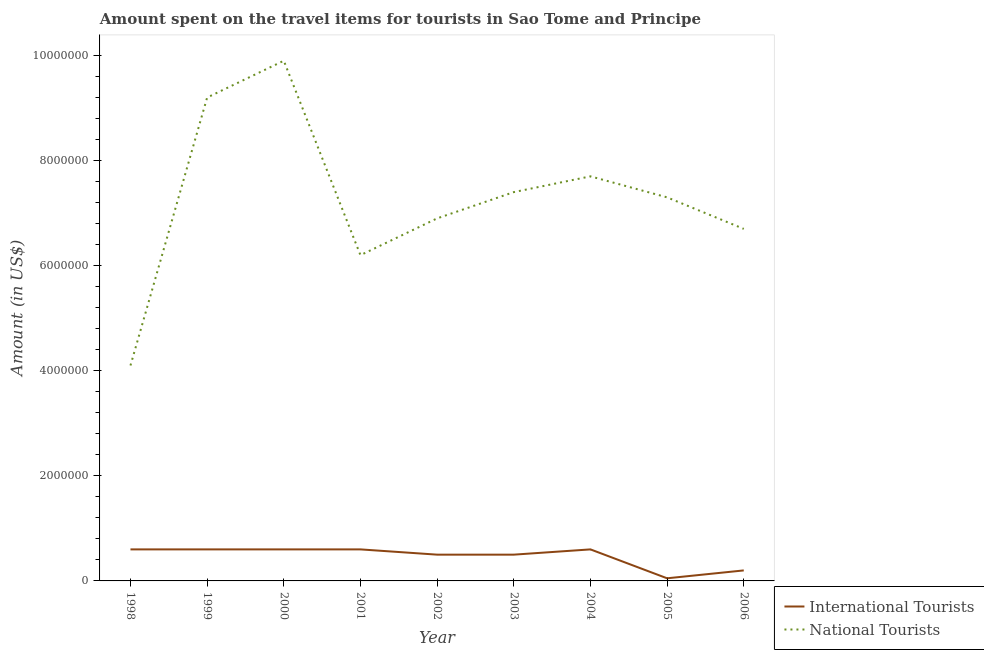Does the line corresponding to amount spent on travel items of international tourists intersect with the line corresponding to amount spent on travel items of national tourists?
Keep it short and to the point. No. What is the amount spent on travel items of national tourists in 2000?
Give a very brief answer. 9.90e+06. Across all years, what is the maximum amount spent on travel items of international tourists?
Your answer should be very brief. 6.00e+05. Across all years, what is the minimum amount spent on travel items of international tourists?
Provide a short and direct response. 5.00e+04. In which year was the amount spent on travel items of national tourists maximum?
Ensure brevity in your answer.  2000. What is the total amount spent on travel items of international tourists in the graph?
Provide a succinct answer. 4.25e+06. What is the difference between the amount spent on travel items of national tourists in 2000 and that in 2002?
Ensure brevity in your answer.  3.00e+06. What is the difference between the amount spent on travel items of national tourists in 2003 and the amount spent on travel items of international tourists in 2002?
Keep it short and to the point. 6.90e+06. What is the average amount spent on travel items of national tourists per year?
Provide a succinct answer. 7.27e+06. In the year 1999, what is the difference between the amount spent on travel items of national tourists and amount spent on travel items of international tourists?
Your response must be concise. 8.60e+06. What is the ratio of the amount spent on travel items of international tourists in 1999 to that in 2000?
Offer a very short reply. 1. What is the difference between the highest and the second highest amount spent on travel items of international tourists?
Provide a succinct answer. 0. What is the difference between the highest and the lowest amount spent on travel items of international tourists?
Your answer should be very brief. 5.50e+05. In how many years, is the amount spent on travel items of national tourists greater than the average amount spent on travel items of national tourists taken over all years?
Provide a succinct answer. 5. Is the sum of the amount spent on travel items of international tourists in 2000 and 2004 greater than the maximum amount spent on travel items of national tourists across all years?
Make the answer very short. No. Is the amount spent on travel items of international tourists strictly less than the amount spent on travel items of national tourists over the years?
Offer a terse response. Yes. Does the graph contain any zero values?
Give a very brief answer. No. Does the graph contain grids?
Give a very brief answer. No. Where does the legend appear in the graph?
Keep it short and to the point. Bottom right. How many legend labels are there?
Give a very brief answer. 2. What is the title of the graph?
Make the answer very short. Amount spent on the travel items for tourists in Sao Tome and Principe. Does "Primary completion rate" appear as one of the legend labels in the graph?
Provide a succinct answer. No. What is the label or title of the Y-axis?
Provide a short and direct response. Amount (in US$). What is the Amount (in US$) of National Tourists in 1998?
Offer a very short reply. 4.10e+06. What is the Amount (in US$) of National Tourists in 1999?
Provide a succinct answer. 9.20e+06. What is the Amount (in US$) of National Tourists in 2000?
Give a very brief answer. 9.90e+06. What is the Amount (in US$) in National Tourists in 2001?
Offer a very short reply. 6.20e+06. What is the Amount (in US$) of National Tourists in 2002?
Give a very brief answer. 6.90e+06. What is the Amount (in US$) in National Tourists in 2003?
Keep it short and to the point. 7.40e+06. What is the Amount (in US$) of National Tourists in 2004?
Give a very brief answer. 7.70e+06. What is the Amount (in US$) of International Tourists in 2005?
Provide a succinct answer. 5.00e+04. What is the Amount (in US$) in National Tourists in 2005?
Provide a short and direct response. 7.30e+06. What is the Amount (in US$) of National Tourists in 2006?
Your answer should be very brief. 6.70e+06. Across all years, what is the maximum Amount (in US$) in International Tourists?
Ensure brevity in your answer.  6.00e+05. Across all years, what is the maximum Amount (in US$) in National Tourists?
Ensure brevity in your answer.  9.90e+06. Across all years, what is the minimum Amount (in US$) in International Tourists?
Provide a succinct answer. 5.00e+04. Across all years, what is the minimum Amount (in US$) of National Tourists?
Provide a succinct answer. 4.10e+06. What is the total Amount (in US$) in International Tourists in the graph?
Your answer should be compact. 4.25e+06. What is the total Amount (in US$) in National Tourists in the graph?
Your answer should be compact. 6.54e+07. What is the difference between the Amount (in US$) of International Tourists in 1998 and that in 1999?
Provide a succinct answer. 0. What is the difference between the Amount (in US$) in National Tourists in 1998 and that in 1999?
Your answer should be very brief. -5.10e+06. What is the difference between the Amount (in US$) in International Tourists in 1998 and that in 2000?
Ensure brevity in your answer.  0. What is the difference between the Amount (in US$) of National Tourists in 1998 and that in 2000?
Provide a short and direct response. -5.80e+06. What is the difference between the Amount (in US$) in National Tourists in 1998 and that in 2001?
Your response must be concise. -2.10e+06. What is the difference between the Amount (in US$) in National Tourists in 1998 and that in 2002?
Offer a very short reply. -2.80e+06. What is the difference between the Amount (in US$) of National Tourists in 1998 and that in 2003?
Keep it short and to the point. -3.30e+06. What is the difference between the Amount (in US$) in International Tourists in 1998 and that in 2004?
Provide a succinct answer. 0. What is the difference between the Amount (in US$) in National Tourists in 1998 and that in 2004?
Offer a terse response. -3.60e+06. What is the difference between the Amount (in US$) in National Tourists in 1998 and that in 2005?
Your answer should be very brief. -3.20e+06. What is the difference between the Amount (in US$) in International Tourists in 1998 and that in 2006?
Provide a short and direct response. 4.00e+05. What is the difference between the Amount (in US$) of National Tourists in 1998 and that in 2006?
Provide a short and direct response. -2.60e+06. What is the difference between the Amount (in US$) in National Tourists in 1999 and that in 2000?
Give a very brief answer. -7.00e+05. What is the difference between the Amount (in US$) of International Tourists in 1999 and that in 2002?
Provide a short and direct response. 1.00e+05. What is the difference between the Amount (in US$) of National Tourists in 1999 and that in 2002?
Provide a succinct answer. 2.30e+06. What is the difference between the Amount (in US$) in International Tourists in 1999 and that in 2003?
Make the answer very short. 1.00e+05. What is the difference between the Amount (in US$) in National Tourists in 1999 and that in 2003?
Provide a short and direct response. 1.80e+06. What is the difference between the Amount (in US$) of International Tourists in 1999 and that in 2004?
Your answer should be compact. 0. What is the difference between the Amount (in US$) of National Tourists in 1999 and that in 2004?
Provide a short and direct response. 1.50e+06. What is the difference between the Amount (in US$) in International Tourists in 1999 and that in 2005?
Your answer should be very brief. 5.50e+05. What is the difference between the Amount (in US$) of National Tourists in 1999 and that in 2005?
Your answer should be compact. 1.90e+06. What is the difference between the Amount (in US$) of National Tourists in 1999 and that in 2006?
Your response must be concise. 2.50e+06. What is the difference between the Amount (in US$) in National Tourists in 2000 and that in 2001?
Provide a succinct answer. 3.70e+06. What is the difference between the Amount (in US$) of International Tourists in 2000 and that in 2002?
Your answer should be compact. 1.00e+05. What is the difference between the Amount (in US$) in National Tourists in 2000 and that in 2003?
Offer a very short reply. 2.50e+06. What is the difference between the Amount (in US$) of National Tourists in 2000 and that in 2004?
Your answer should be compact. 2.20e+06. What is the difference between the Amount (in US$) in International Tourists in 2000 and that in 2005?
Offer a terse response. 5.50e+05. What is the difference between the Amount (in US$) in National Tourists in 2000 and that in 2005?
Offer a very short reply. 2.60e+06. What is the difference between the Amount (in US$) of International Tourists in 2000 and that in 2006?
Ensure brevity in your answer.  4.00e+05. What is the difference between the Amount (in US$) of National Tourists in 2000 and that in 2006?
Make the answer very short. 3.20e+06. What is the difference between the Amount (in US$) of International Tourists in 2001 and that in 2002?
Give a very brief answer. 1.00e+05. What is the difference between the Amount (in US$) in National Tourists in 2001 and that in 2002?
Your response must be concise. -7.00e+05. What is the difference between the Amount (in US$) of International Tourists in 2001 and that in 2003?
Offer a very short reply. 1.00e+05. What is the difference between the Amount (in US$) in National Tourists in 2001 and that in 2003?
Provide a succinct answer. -1.20e+06. What is the difference between the Amount (in US$) in International Tourists in 2001 and that in 2004?
Your answer should be compact. 0. What is the difference between the Amount (in US$) in National Tourists in 2001 and that in 2004?
Your answer should be compact. -1.50e+06. What is the difference between the Amount (in US$) of National Tourists in 2001 and that in 2005?
Keep it short and to the point. -1.10e+06. What is the difference between the Amount (in US$) in International Tourists in 2001 and that in 2006?
Keep it short and to the point. 4.00e+05. What is the difference between the Amount (in US$) of National Tourists in 2001 and that in 2006?
Your answer should be very brief. -5.00e+05. What is the difference between the Amount (in US$) in National Tourists in 2002 and that in 2003?
Your answer should be very brief. -5.00e+05. What is the difference between the Amount (in US$) in International Tourists in 2002 and that in 2004?
Offer a terse response. -1.00e+05. What is the difference between the Amount (in US$) in National Tourists in 2002 and that in 2004?
Give a very brief answer. -8.00e+05. What is the difference between the Amount (in US$) in International Tourists in 2002 and that in 2005?
Your answer should be compact. 4.50e+05. What is the difference between the Amount (in US$) in National Tourists in 2002 and that in 2005?
Your answer should be very brief. -4.00e+05. What is the difference between the Amount (in US$) of International Tourists in 2002 and that in 2006?
Ensure brevity in your answer.  3.00e+05. What is the difference between the Amount (in US$) of International Tourists in 2003 and that in 2005?
Ensure brevity in your answer.  4.50e+05. What is the difference between the Amount (in US$) in National Tourists in 2003 and that in 2005?
Your answer should be very brief. 1.00e+05. What is the difference between the Amount (in US$) in National Tourists in 2003 and that in 2006?
Offer a very short reply. 7.00e+05. What is the difference between the Amount (in US$) in International Tourists in 2004 and that in 2005?
Provide a succinct answer. 5.50e+05. What is the difference between the Amount (in US$) in National Tourists in 2004 and that in 2005?
Offer a terse response. 4.00e+05. What is the difference between the Amount (in US$) of National Tourists in 2004 and that in 2006?
Offer a terse response. 1.00e+06. What is the difference between the Amount (in US$) in International Tourists in 2005 and that in 2006?
Ensure brevity in your answer.  -1.50e+05. What is the difference between the Amount (in US$) of National Tourists in 2005 and that in 2006?
Offer a terse response. 6.00e+05. What is the difference between the Amount (in US$) in International Tourists in 1998 and the Amount (in US$) in National Tourists in 1999?
Your response must be concise. -8.60e+06. What is the difference between the Amount (in US$) in International Tourists in 1998 and the Amount (in US$) in National Tourists in 2000?
Offer a terse response. -9.30e+06. What is the difference between the Amount (in US$) of International Tourists in 1998 and the Amount (in US$) of National Tourists in 2001?
Give a very brief answer. -5.60e+06. What is the difference between the Amount (in US$) in International Tourists in 1998 and the Amount (in US$) in National Tourists in 2002?
Your response must be concise. -6.30e+06. What is the difference between the Amount (in US$) in International Tourists in 1998 and the Amount (in US$) in National Tourists in 2003?
Keep it short and to the point. -6.80e+06. What is the difference between the Amount (in US$) of International Tourists in 1998 and the Amount (in US$) of National Tourists in 2004?
Provide a succinct answer. -7.10e+06. What is the difference between the Amount (in US$) in International Tourists in 1998 and the Amount (in US$) in National Tourists in 2005?
Offer a terse response. -6.70e+06. What is the difference between the Amount (in US$) of International Tourists in 1998 and the Amount (in US$) of National Tourists in 2006?
Your response must be concise. -6.10e+06. What is the difference between the Amount (in US$) in International Tourists in 1999 and the Amount (in US$) in National Tourists in 2000?
Ensure brevity in your answer.  -9.30e+06. What is the difference between the Amount (in US$) in International Tourists in 1999 and the Amount (in US$) in National Tourists in 2001?
Offer a very short reply. -5.60e+06. What is the difference between the Amount (in US$) of International Tourists in 1999 and the Amount (in US$) of National Tourists in 2002?
Offer a very short reply. -6.30e+06. What is the difference between the Amount (in US$) in International Tourists in 1999 and the Amount (in US$) in National Tourists in 2003?
Your answer should be compact. -6.80e+06. What is the difference between the Amount (in US$) of International Tourists in 1999 and the Amount (in US$) of National Tourists in 2004?
Ensure brevity in your answer.  -7.10e+06. What is the difference between the Amount (in US$) of International Tourists in 1999 and the Amount (in US$) of National Tourists in 2005?
Give a very brief answer. -6.70e+06. What is the difference between the Amount (in US$) of International Tourists in 1999 and the Amount (in US$) of National Tourists in 2006?
Give a very brief answer. -6.10e+06. What is the difference between the Amount (in US$) in International Tourists in 2000 and the Amount (in US$) in National Tourists in 2001?
Your response must be concise. -5.60e+06. What is the difference between the Amount (in US$) in International Tourists in 2000 and the Amount (in US$) in National Tourists in 2002?
Provide a succinct answer. -6.30e+06. What is the difference between the Amount (in US$) of International Tourists in 2000 and the Amount (in US$) of National Tourists in 2003?
Offer a very short reply. -6.80e+06. What is the difference between the Amount (in US$) in International Tourists in 2000 and the Amount (in US$) in National Tourists in 2004?
Ensure brevity in your answer.  -7.10e+06. What is the difference between the Amount (in US$) of International Tourists in 2000 and the Amount (in US$) of National Tourists in 2005?
Offer a very short reply. -6.70e+06. What is the difference between the Amount (in US$) of International Tourists in 2000 and the Amount (in US$) of National Tourists in 2006?
Your answer should be compact. -6.10e+06. What is the difference between the Amount (in US$) in International Tourists in 2001 and the Amount (in US$) in National Tourists in 2002?
Keep it short and to the point. -6.30e+06. What is the difference between the Amount (in US$) in International Tourists in 2001 and the Amount (in US$) in National Tourists in 2003?
Give a very brief answer. -6.80e+06. What is the difference between the Amount (in US$) in International Tourists in 2001 and the Amount (in US$) in National Tourists in 2004?
Give a very brief answer. -7.10e+06. What is the difference between the Amount (in US$) of International Tourists in 2001 and the Amount (in US$) of National Tourists in 2005?
Ensure brevity in your answer.  -6.70e+06. What is the difference between the Amount (in US$) of International Tourists in 2001 and the Amount (in US$) of National Tourists in 2006?
Provide a succinct answer. -6.10e+06. What is the difference between the Amount (in US$) of International Tourists in 2002 and the Amount (in US$) of National Tourists in 2003?
Provide a short and direct response. -6.90e+06. What is the difference between the Amount (in US$) in International Tourists in 2002 and the Amount (in US$) in National Tourists in 2004?
Offer a very short reply. -7.20e+06. What is the difference between the Amount (in US$) in International Tourists in 2002 and the Amount (in US$) in National Tourists in 2005?
Make the answer very short. -6.80e+06. What is the difference between the Amount (in US$) in International Tourists in 2002 and the Amount (in US$) in National Tourists in 2006?
Provide a succinct answer. -6.20e+06. What is the difference between the Amount (in US$) in International Tourists in 2003 and the Amount (in US$) in National Tourists in 2004?
Provide a succinct answer. -7.20e+06. What is the difference between the Amount (in US$) of International Tourists in 2003 and the Amount (in US$) of National Tourists in 2005?
Offer a terse response. -6.80e+06. What is the difference between the Amount (in US$) in International Tourists in 2003 and the Amount (in US$) in National Tourists in 2006?
Make the answer very short. -6.20e+06. What is the difference between the Amount (in US$) of International Tourists in 2004 and the Amount (in US$) of National Tourists in 2005?
Your answer should be very brief. -6.70e+06. What is the difference between the Amount (in US$) of International Tourists in 2004 and the Amount (in US$) of National Tourists in 2006?
Offer a terse response. -6.10e+06. What is the difference between the Amount (in US$) in International Tourists in 2005 and the Amount (in US$) in National Tourists in 2006?
Keep it short and to the point. -6.65e+06. What is the average Amount (in US$) in International Tourists per year?
Give a very brief answer. 4.72e+05. What is the average Amount (in US$) in National Tourists per year?
Ensure brevity in your answer.  7.27e+06. In the year 1998, what is the difference between the Amount (in US$) of International Tourists and Amount (in US$) of National Tourists?
Make the answer very short. -3.50e+06. In the year 1999, what is the difference between the Amount (in US$) of International Tourists and Amount (in US$) of National Tourists?
Give a very brief answer. -8.60e+06. In the year 2000, what is the difference between the Amount (in US$) of International Tourists and Amount (in US$) of National Tourists?
Provide a succinct answer. -9.30e+06. In the year 2001, what is the difference between the Amount (in US$) in International Tourists and Amount (in US$) in National Tourists?
Keep it short and to the point. -5.60e+06. In the year 2002, what is the difference between the Amount (in US$) in International Tourists and Amount (in US$) in National Tourists?
Give a very brief answer. -6.40e+06. In the year 2003, what is the difference between the Amount (in US$) in International Tourists and Amount (in US$) in National Tourists?
Ensure brevity in your answer.  -6.90e+06. In the year 2004, what is the difference between the Amount (in US$) of International Tourists and Amount (in US$) of National Tourists?
Your response must be concise. -7.10e+06. In the year 2005, what is the difference between the Amount (in US$) of International Tourists and Amount (in US$) of National Tourists?
Offer a very short reply. -7.25e+06. In the year 2006, what is the difference between the Amount (in US$) of International Tourists and Amount (in US$) of National Tourists?
Provide a succinct answer. -6.50e+06. What is the ratio of the Amount (in US$) in International Tourists in 1998 to that in 1999?
Ensure brevity in your answer.  1. What is the ratio of the Amount (in US$) of National Tourists in 1998 to that in 1999?
Keep it short and to the point. 0.45. What is the ratio of the Amount (in US$) in National Tourists in 1998 to that in 2000?
Offer a terse response. 0.41. What is the ratio of the Amount (in US$) of International Tourists in 1998 to that in 2001?
Your response must be concise. 1. What is the ratio of the Amount (in US$) of National Tourists in 1998 to that in 2001?
Provide a short and direct response. 0.66. What is the ratio of the Amount (in US$) in International Tourists in 1998 to that in 2002?
Your response must be concise. 1.2. What is the ratio of the Amount (in US$) of National Tourists in 1998 to that in 2002?
Your answer should be compact. 0.59. What is the ratio of the Amount (in US$) of International Tourists in 1998 to that in 2003?
Provide a short and direct response. 1.2. What is the ratio of the Amount (in US$) of National Tourists in 1998 to that in 2003?
Offer a terse response. 0.55. What is the ratio of the Amount (in US$) in International Tourists in 1998 to that in 2004?
Keep it short and to the point. 1. What is the ratio of the Amount (in US$) in National Tourists in 1998 to that in 2004?
Your response must be concise. 0.53. What is the ratio of the Amount (in US$) in National Tourists in 1998 to that in 2005?
Ensure brevity in your answer.  0.56. What is the ratio of the Amount (in US$) of National Tourists in 1998 to that in 2006?
Provide a succinct answer. 0.61. What is the ratio of the Amount (in US$) of International Tourists in 1999 to that in 2000?
Keep it short and to the point. 1. What is the ratio of the Amount (in US$) in National Tourists in 1999 to that in 2000?
Offer a very short reply. 0.93. What is the ratio of the Amount (in US$) in National Tourists in 1999 to that in 2001?
Give a very brief answer. 1.48. What is the ratio of the Amount (in US$) of International Tourists in 1999 to that in 2002?
Your answer should be very brief. 1.2. What is the ratio of the Amount (in US$) of National Tourists in 1999 to that in 2002?
Your answer should be compact. 1.33. What is the ratio of the Amount (in US$) in National Tourists in 1999 to that in 2003?
Your answer should be compact. 1.24. What is the ratio of the Amount (in US$) of International Tourists in 1999 to that in 2004?
Your answer should be very brief. 1. What is the ratio of the Amount (in US$) in National Tourists in 1999 to that in 2004?
Your response must be concise. 1.19. What is the ratio of the Amount (in US$) of International Tourists in 1999 to that in 2005?
Give a very brief answer. 12. What is the ratio of the Amount (in US$) in National Tourists in 1999 to that in 2005?
Ensure brevity in your answer.  1.26. What is the ratio of the Amount (in US$) in International Tourists in 1999 to that in 2006?
Provide a succinct answer. 3. What is the ratio of the Amount (in US$) of National Tourists in 1999 to that in 2006?
Your answer should be very brief. 1.37. What is the ratio of the Amount (in US$) of National Tourists in 2000 to that in 2001?
Your response must be concise. 1.6. What is the ratio of the Amount (in US$) in National Tourists in 2000 to that in 2002?
Your answer should be compact. 1.43. What is the ratio of the Amount (in US$) of National Tourists in 2000 to that in 2003?
Give a very brief answer. 1.34. What is the ratio of the Amount (in US$) of National Tourists in 2000 to that in 2004?
Your answer should be compact. 1.29. What is the ratio of the Amount (in US$) of International Tourists in 2000 to that in 2005?
Provide a short and direct response. 12. What is the ratio of the Amount (in US$) in National Tourists in 2000 to that in 2005?
Keep it short and to the point. 1.36. What is the ratio of the Amount (in US$) in International Tourists in 2000 to that in 2006?
Keep it short and to the point. 3. What is the ratio of the Amount (in US$) of National Tourists in 2000 to that in 2006?
Make the answer very short. 1.48. What is the ratio of the Amount (in US$) in International Tourists in 2001 to that in 2002?
Your answer should be very brief. 1.2. What is the ratio of the Amount (in US$) in National Tourists in 2001 to that in 2002?
Give a very brief answer. 0.9. What is the ratio of the Amount (in US$) in National Tourists in 2001 to that in 2003?
Keep it short and to the point. 0.84. What is the ratio of the Amount (in US$) in National Tourists in 2001 to that in 2004?
Give a very brief answer. 0.81. What is the ratio of the Amount (in US$) of National Tourists in 2001 to that in 2005?
Give a very brief answer. 0.85. What is the ratio of the Amount (in US$) of National Tourists in 2001 to that in 2006?
Your answer should be very brief. 0.93. What is the ratio of the Amount (in US$) of International Tourists in 2002 to that in 2003?
Your answer should be compact. 1. What is the ratio of the Amount (in US$) of National Tourists in 2002 to that in 2003?
Make the answer very short. 0.93. What is the ratio of the Amount (in US$) in National Tourists in 2002 to that in 2004?
Provide a short and direct response. 0.9. What is the ratio of the Amount (in US$) of National Tourists in 2002 to that in 2005?
Your answer should be compact. 0.95. What is the ratio of the Amount (in US$) of International Tourists in 2002 to that in 2006?
Your answer should be compact. 2.5. What is the ratio of the Amount (in US$) in National Tourists in 2002 to that in 2006?
Your answer should be compact. 1.03. What is the ratio of the Amount (in US$) in International Tourists in 2003 to that in 2005?
Provide a short and direct response. 10. What is the ratio of the Amount (in US$) in National Tourists in 2003 to that in 2005?
Your response must be concise. 1.01. What is the ratio of the Amount (in US$) in International Tourists in 2003 to that in 2006?
Offer a very short reply. 2.5. What is the ratio of the Amount (in US$) of National Tourists in 2003 to that in 2006?
Make the answer very short. 1.1. What is the ratio of the Amount (in US$) in International Tourists in 2004 to that in 2005?
Your answer should be compact. 12. What is the ratio of the Amount (in US$) in National Tourists in 2004 to that in 2005?
Your answer should be compact. 1.05. What is the ratio of the Amount (in US$) of National Tourists in 2004 to that in 2006?
Make the answer very short. 1.15. What is the ratio of the Amount (in US$) in National Tourists in 2005 to that in 2006?
Ensure brevity in your answer.  1.09. What is the difference between the highest and the lowest Amount (in US$) in International Tourists?
Provide a short and direct response. 5.50e+05. What is the difference between the highest and the lowest Amount (in US$) in National Tourists?
Your answer should be very brief. 5.80e+06. 